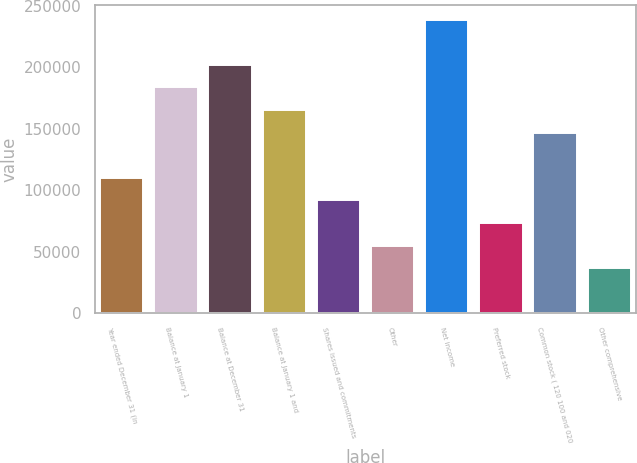Convert chart to OTSL. <chart><loc_0><loc_0><loc_500><loc_500><bar_chart><fcel>Year ended December 31 (in<fcel>Balance at January 1<fcel>Balance at December 31<fcel>Balance at January 1 and<fcel>Shares issued and commitments<fcel>Other<fcel>Net income<fcel>Preferred stock<fcel>Common stock ( 120 100 and 020<fcel>Other comprehensive<nl><fcel>110145<fcel>183573<fcel>201930<fcel>165216<fcel>91788.5<fcel>55074.7<fcel>238644<fcel>73431.6<fcel>146859<fcel>36717.8<nl></chart> 